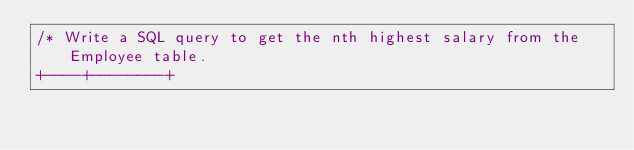<code> <loc_0><loc_0><loc_500><loc_500><_SQL_>/* Write a SQL query to get the nth highest salary from the Employee table.
+----+--------+</code> 